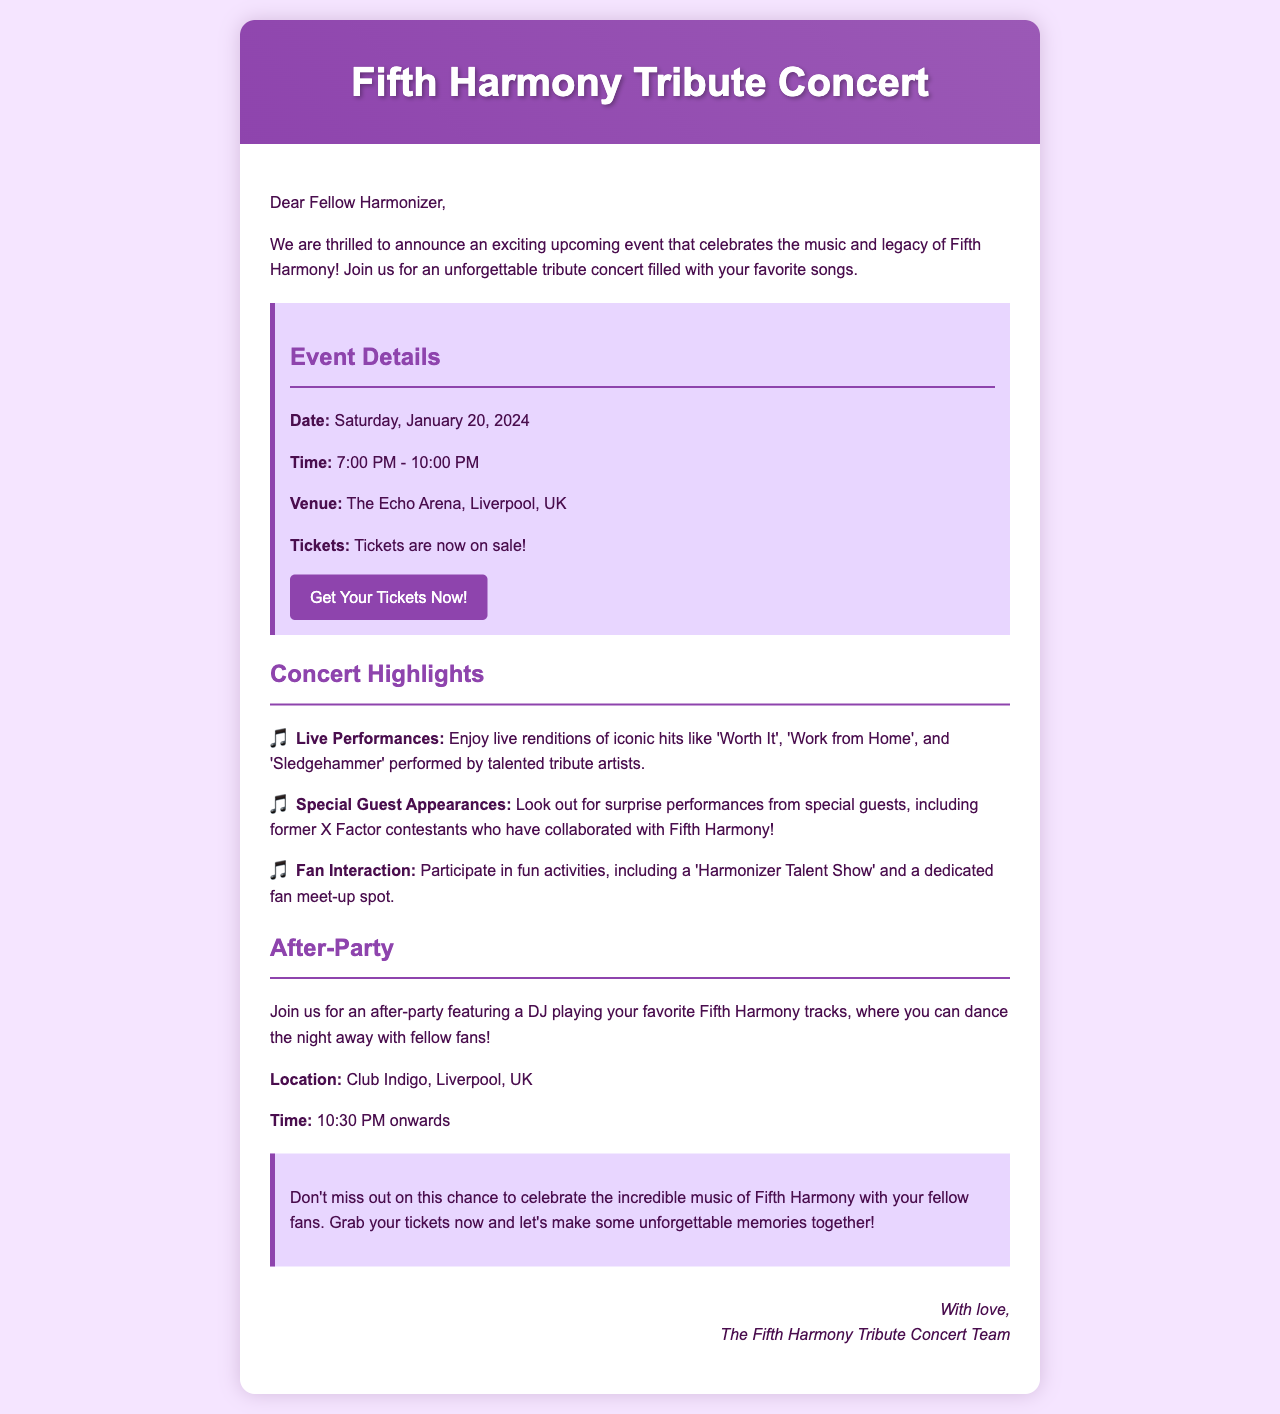What is the date of the concert? The concert date is mentioned in the event details section of the document.
Answer: Saturday, January 20, 2024 What time does the concert start? The starting time of the concert is provided under the event details section.
Answer: 7:00 PM Where is the concert venue located? The venue is specified in the event details section as well.
Answer: The Echo Arena, Liverpool, UK What is one of the iconic songs to be performed at the concert? Iconic songs are listed in the concert highlights section of the document.
Answer: Worth It What type of activities will fans participate in? The types of activities for fans are described in the concert highlights section.
Answer: Harmonizer Talent Show Where is the after-party taking place? The after-party location is called out explicitly in the after-party section.
Answer: Club Indigo, Liverpool, UK What is the start time for the after-party? The start time for the after-party is clearly mentioned in the document.
Answer: 10:30 PM onwards Who organized this concert event? The signature at the end of the document identifies who organized the event.
Answer: The Fifth Harmony Tribute Concert Team What color is used for the concert's header? The color scheme for the header can be inferred from the document's style description.
Answer: Gradient of purple 